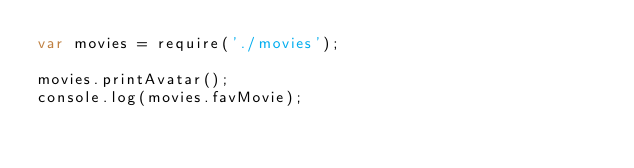<code> <loc_0><loc_0><loc_500><loc_500><_JavaScript_>var movies = require('./movies');

movies.printAvatar();
console.log(movies.favMovie);
</code> 